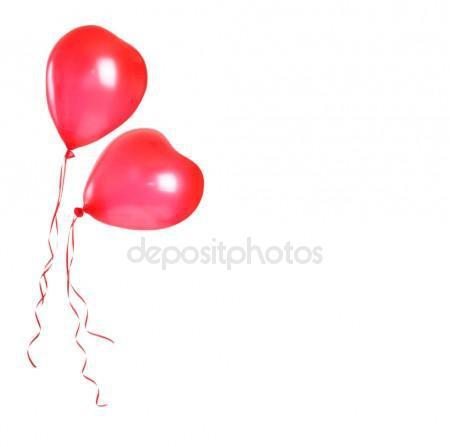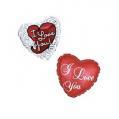The first image is the image on the left, the second image is the image on the right. Assess this claim about the two images: "At least one balloon is shaped like a number.". Correct or not? Answer yes or no. No. The first image is the image on the left, the second image is the image on the right. For the images displayed, is the sentence "One image shows a balloon that is in the shape of a number" factually correct? Answer yes or no. No. 